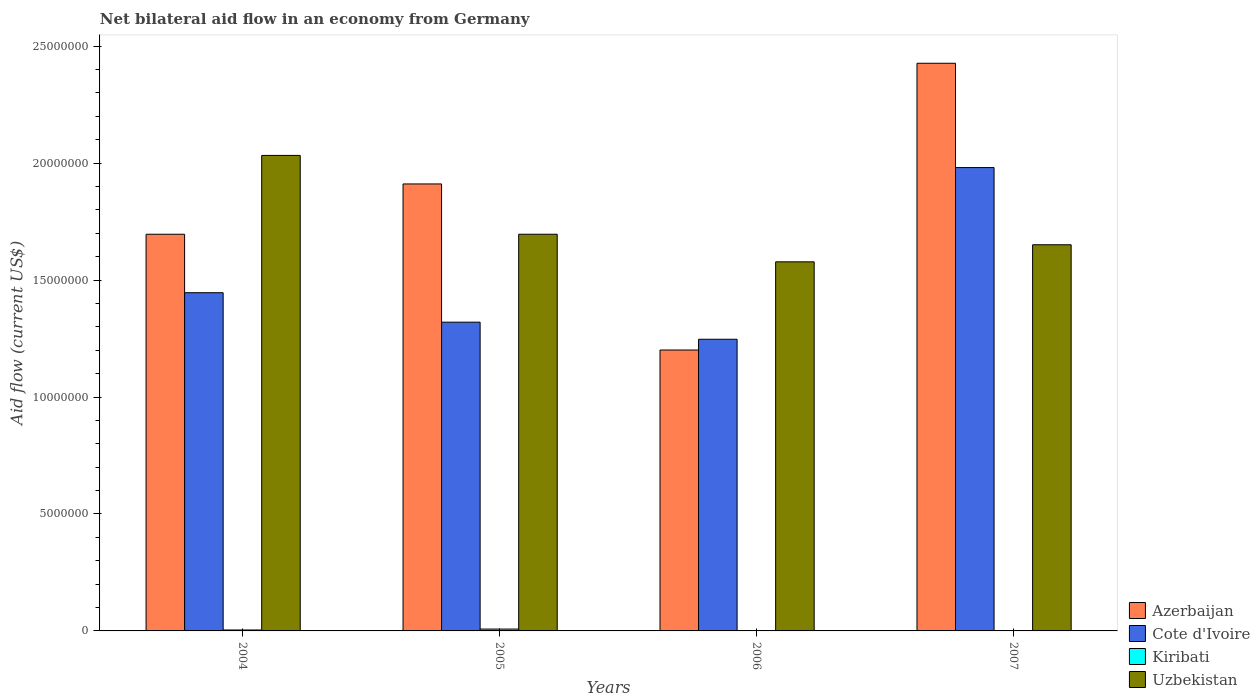How many groups of bars are there?
Make the answer very short. 4. Are the number of bars per tick equal to the number of legend labels?
Your response must be concise. Yes. How many bars are there on the 1st tick from the right?
Provide a short and direct response. 4. In how many cases, is the number of bars for a given year not equal to the number of legend labels?
Make the answer very short. 0. What is the net bilateral aid flow in Uzbekistan in 2005?
Offer a terse response. 1.70e+07. Across all years, what is the maximum net bilateral aid flow in Azerbaijan?
Offer a very short reply. 2.43e+07. Across all years, what is the minimum net bilateral aid flow in Uzbekistan?
Ensure brevity in your answer.  1.58e+07. What is the total net bilateral aid flow in Cote d'Ivoire in the graph?
Make the answer very short. 5.99e+07. What is the difference between the net bilateral aid flow in Uzbekistan in 2004 and that in 2007?
Your answer should be compact. 3.82e+06. What is the difference between the net bilateral aid flow in Cote d'Ivoire in 2007 and the net bilateral aid flow in Azerbaijan in 2005?
Your answer should be compact. 7.00e+05. What is the average net bilateral aid flow in Azerbaijan per year?
Keep it short and to the point. 1.81e+07. In the year 2005, what is the difference between the net bilateral aid flow in Cote d'Ivoire and net bilateral aid flow in Azerbaijan?
Keep it short and to the point. -5.91e+06. In how many years, is the net bilateral aid flow in Kiribati greater than 10000000 US$?
Make the answer very short. 0. What is the ratio of the net bilateral aid flow in Uzbekistan in 2004 to that in 2007?
Your answer should be compact. 1.23. Is the difference between the net bilateral aid flow in Cote d'Ivoire in 2004 and 2006 greater than the difference between the net bilateral aid flow in Azerbaijan in 2004 and 2006?
Provide a succinct answer. No. What is the difference between the highest and the second highest net bilateral aid flow in Azerbaijan?
Your answer should be very brief. 5.16e+06. What is the difference between the highest and the lowest net bilateral aid flow in Uzbekistan?
Your response must be concise. 4.55e+06. In how many years, is the net bilateral aid flow in Kiribati greater than the average net bilateral aid flow in Kiribati taken over all years?
Provide a short and direct response. 2. What does the 4th bar from the left in 2007 represents?
Your answer should be very brief. Uzbekistan. What does the 3rd bar from the right in 2006 represents?
Your response must be concise. Cote d'Ivoire. How many bars are there?
Ensure brevity in your answer.  16. What is the difference between two consecutive major ticks on the Y-axis?
Make the answer very short. 5.00e+06. Are the values on the major ticks of Y-axis written in scientific E-notation?
Make the answer very short. No. Where does the legend appear in the graph?
Your answer should be very brief. Bottom right. How are the legend labels stacked?
Offer a very short reply. Vertical. What is the title of the graph?
Offer a very short reply. Net bilateral aid flow in an economy from Germany. What is the label or title of the Y-axis?
Provide a succinct answer. Aid flow (current US$). What is the Aid flow (current US$) of Azerbaijan in 2004?
Ensure brevity in your answer.  1.70e+07. What is the Aid flow (current US$) of Cote d'Ivoire in 2004?
Your answer should be compact. 1.45e+07. What is the Aid flow (current US$) of Uzbekistan in 2004?
Your response must be concise. 2.03e+07. What is the Aid flow (current US$) of Azerbaijan in 2005?
Your answer should be compact. 1.91e+07. What is the Aid flow (current US$) of Cote d'Ivoire in 2005?
Offer a very short reply. 1.32e+07. What is the Aid flow (current US$) of Uzbekistan in 2005?
Give a very brief answer. 1.70e+07. What is the Aid flow (current US$) in Azerbaijan in 2006?
Your answer should be compact. 1.20e+07. What is the Aid flow (current US$) of Cote d'Ivoire in 2006?
Your answer should be very brief. 1.25e+07. What is the Aid flow (current US$) of Kiribati in 2006?
Your answer should be compact. 10000. What is the Aid flow (current US$) in Uzbekistan in 2006?
Ensure brevity in your answer.  1.58e+07. What is the Aid flow (current US$) in Azerbaijan in 2007?
Provide a short and direct response. 2.43e+07. What is the Aid flow (current US$) in Cote d'Ivoire in 2007?
Keep it short and to the point. 1.98e+07. What is the Aid flow (current US$) of Uzbekistan in 2007?
Offer a terse response. 1.65e+07. Across all years, what is the maximum Aid flow (current US$) in Azerbaijan?
Make the answer very short. 2.43e+07. Across all years, what is the maximum Aid flow (current US$) of Cote d'Ivoire?
Your answer should be very brief. 1.98e+07. Across all years, what is the maximum Aid flow (current US$) of Kiribati?
Offer a very short reply. 8.00e+04. Across all years, what is the maximum Aid flow (current US$) in Uzbekistan?
Ensure brevity in your answer.  2.03e+07. Across all years, what is the minimum Aid flow (current US$) in Azerbaijan?
Your answer should be compact. 1.20e+07. Across all years, what is the minimum Aid flow (current US$) of Cote d'Ivoire?
Ensure brevity in your answer.  1.25e+07. Across all years, what is the minimum Aid flow (current US$) of Uzbekistan?
Provide a short and direct response. 1.58e+07. What is the total Aid flow (current US$) in Azerbaijan in the graph?
Provide a succinct answer. 7.24e+07. What is the total Aid flow (current US$) in Cote d'Ivoire in the graph?
Provide a succinct answer. 5.99e+07. What is the total Aid flow (current US$) of Uzbekistan in the graph?
Provide a short and direct response. 6.96e+07. What is the difference between the Aid flow (current US$) in Azerbaijan in 2004 and that in 2005?
Keep it short and to the point. -2.15e+06. What is the difference between the Aid flow (current US$) of Cote d'Ivoire in 2004 and that in 2005?
Keep it short and to the point. 1.26e+06. What is the difference between the Aid flow (current US$) in Uzbekistan in 2004 and that in 2005?
Make the answer very short. 3.37e+06. What is the difference between the Aid flow (current US$) in Azerbaijan in 2004 and that in 2006?
Make the answer very short. 4.95e+06. What is the difference between the Aid flow (current US$) in Cote d'Ivoire in 2004 and that in 2006?
Your answer should be compact. 1.99e+06. What is the difference between the Aid flow (current US$) of Uzbekistan in 2004 and that in 2006?
Offer a very short reply. 4.55e+06. What is the difference between the Aid flow (current US$) of Azerbaijan in 2004 and that in 2007?
Keep it short and to the point. -7.31e+06. What is the difference between the Aid flow (current US$) of Cote d'Ivoire in 2004 and that in 2007?
Your answer should be very brief. -5.35e+06. What is the difference between the Aid flow (current US$) of Kiribati in 2004 and that in 2007?
Make the answer very short. 3.00e+04. What is the difference between the Aid flow (current US$) in Uzbekistan in 2004 and that in 2007?
Offer a terse response. 3.82e+06. What is the difference between the Aid flow (current US$) of Azerbaijan in 2005 and that in 2006?
Your answer should be very brief. 7.10e+06. What is the difference between the Aid flow (current US$) of Cote d'Ivoire in 2005 and that in 2006?
Your answer should be very brief. 7.30e+05. What is the difference between the Aid flow (current US$) of Kiribati in 2005 and that in 2006?
Provide a short and direct response. 7.00e+04. What is the difference between the Aid flow (current US$) in Uzbekistan in 2005 and that in 2006?
Keep it short and to the point. 1.18e+06. What is the difference between the Aid flow (current US$) of Azerbaijan in 2005 and that in 2007?
Your response must be concise. -5.16e+06. What is the difference between the Aid flow (current US$) of Cote d'Ivoire in 2005 and that in 2007?
Make the answer very short. -6.61e+06. What is the difference between the Aid flow (current US$) in Kiribati in 2005 and that in 2007?
Ensure brevity in your answer.  7.00e+04. What is the difference between the Aid flow (current US$) of Azerbaijan in 2006 and that in 2007?
Offer a terse response. -1.23e+07. What is the difference between the Aid flow (current US$) in Cote d'Ivoire in 2006 and that in 2007?
Offer a very short reply. -7.34e+06. What is the difference between the Aid flow (current US$) in Uzbekistan in 2006 and that in 2007?
Give a very brief answer. -7.30e+05. What is the difference between the Aid flow (current US$) in Azerbaijan in 2004 and the Aid flow (current US$) in Cote d'Ivoire in 2005?
Provide a short and direct response. 3.76e+06. What is the difference between the Aid flow (current US$) of Azerbaijan in 2004 and the Aid flow (current US$) of Kiribati in 2005?
Provide a short and direct response. 1.69e+07. What is the difference between the Aid flow (current US$) of Cote d'Ivoire in 2004 and the Aid flow (current US$) of Kiribati in 2005?
Make the answer very short. 1.44e+07. What is the difference between the Aid flow (current US$) in Cote d'Ivoire in 2004 and the Aid flow (current US$) in Uzbekistan in 2005?
Keep it short and to the point. -2.50e+06. What is the difference between the Aid flow (current US$) of Kiribati in 2004 and the Aid flow (current US$) of Uzbekistan in 2005?
Your response must be concise. -1.69e+07. What is the difference between the Aid flow (current US$) in Azerbaijan in 2004 and the Aid flow (current US$) in Cote d'Ivoire in 2006?
Ensure brevity in your answer.  4.49e+06. What is the difference between the Aid flow (current US$) of Azerbaijan in 2004 and the Aid flow (current US$) of Kiribati in 2006?
Your answer should be compact. 1.70e+07. What is the difference between the Aid flow (current US$) of Azerbaijan in 2004 and the Aid flow (current US$) of Uzbekistan in 2006?
Your response must be concise. 1.18e+06. What is the difference between the Aid flow (current US$) in Cote d'Ivoire in 2004 and the Aid flow (current US$) in Kiribati in 2006?
Your answer should be very brief. 1.44e+07. What is the difference between the Aid flow (current US$) in Cote d'Ivoire in 2004 and the Aid flow (current US$) in Uzbekistan in 2006?
Your answer should be compact. -1.32e+06. What is the difference between the Aid flow (current US$) of Kiribati in 2004 and the Aid flow (current US$) of Uzbekistan in 2006?
Keep it short and to the point. -1.57e+07. What is the difference between the Aid flow (current US$) of Azerbaijan in 2004 and the Aid flow (current US$) of Cote d'Ivoire in 2007?
Your response must be concise. -2.85e+06. What is the difference between the Aid flow (current US$) in Azerbaijan in 2004 and the Aid flow (current US$) in Kiribati in 2007?
Provide a succinct answer. 1.70e+07. What is the difference between the Aid flow (current US$) in Azerbaijan in 2004 and the Aid flow (current US$) in Uzbekistan in 2007?
Your answer should be very brief. 4.50e+05. What is the difference between the Aid flow (current US$) in Cote d'Ivoire in 2004 and the Aid flow (current US$) in Kiribati in 2007?
Make the answer very short. 1.44e+07. What is the difference between the Aid flow (current US$) in Cote d'Ivoire in 2004 and the Aid flow (current US$) in Uzbekistan in 2007?
Keep it short and to the point. -2.05e+06. What is the difference between the Aid flow (current US$) of Kiribati in 2004 and the Aid flow (current US$) of Uzbekistan in 2007?
Offer a very short reply. -1.65e+07. What is the difference between the Aid flow (current US$) of Azerbaijan in 2005 and the Aid flow (current US$) of Cote d'Ivoire in 2006?
Make the answer very short. 6.64e+06. What is the difference between the Aid flow (current US$) of Azerbaijan in 2005 and the Aid flow (current US$) of Kiribati in 2006?
Your response must be concise. 1.91e+07. What is the difference between the Aid flow (current US$) in Azerbaijan in 2005 and the Aid flow (current US$) in Uzbekistan in 2006?
Offer a very short reply. 3.33e+06. What is the difference between the Aid flow (current US$) of Cote d'Ivoire in 2005 and the Aid flow (current US$) of Kiribati in 2006?
Your answer should be very brief. 1.32e+07. What is the difference between the Aid flow (current US$) of Cote d'Ivoire in 2005 and the Aid flow (current US$) of Uzbekistan in 2006?
Ensure brevity in your answer.  -2.58e+06. What is the difference between the Aid flow (current US$) in Kiribati in 2005 and the Aid flow (current US$) in Uzbekistan in 2006?
Offer a terse response. -1.57e+07. What is the difference between the Aid flow (current US$) in Azerbaijan in 2005 and the Aid flow (current US$) in Cote d'Ivoire in 2007?
Provide a short and direct response. -7.00e+05. What is the difference between the Aid flow (current US$) of Azerbaijan in 2005 and the Aid flow (current US$) of Kiribati in 2007?
Make the answer very short. 1.91e+07. What is the difference between the Aid flow (current US$) of Azerbaijan in 2005 and the Aid flow (current US$) of Uzbekistan in 2007?
Provide a succinct answer. 2.60e+06. What is the difference between the Aid flow (current US$) in Cote d'Ivoire in 2005 and the Aid flow (current US$) in Kiribati in 2007?
Give a very brief answer. 1.32e+07. What is the difference between the Aid flow (current US$) in Cote d'Ivoire in 2005 and the Aid flow (current US$) in Uzbekistan in 2007?
Provide a succinct answer. -3.31e+06. What is the difference between the Aid flow (current US$) of Kiribati in 2005 and the Aid flow (current US$) of Uzbekistan in 2007?
Give a very brief answer. -1.64e+07. What is the difference between the Aid flow (current US$) of Azerbaijan in 2006 and the Aid flow (current US$) of Cote d'Ivoire in 2007?
Keep it short and to the point. -7.80e+06. What is the difference between the Aid flow (current US$) in Azerbaijan in 2006 and the Aid flow (current US$) in Kiribati in 2007?
Make the answer very short. 1.20e+07. What is the difference between the Aid flow (current US$) in Azerbaijan in 2006 and the Aid flow (current US$) in Uzbekistan in 2007?
Offer a very short reply. -4.50e+06. What is the difference between the Aid flow (current US$) of Cote d'Ivoire in 2006 and the Aid flow (current US$) of Kiribati in 2007?
Your answer should be compact. 1.25e+07. What is the difference between the Aid flow (current US$) in Cote d'Ivoire in 2006 and the Aid flow (current US$) in Uzbekistan in 2007?
Provide a succinct answer. -4.04e+06. What is the difference between the Aid flow (current US$) of Kiribati in 2006 and the Aid flow (current US$) of Uzbekistan in 2007?
Provide a short and direct response. -1.65e+07. What is the average Aid flow (current US$) of Azerbaijan per year?
Provide a succinct answer. 1.81e+07. What is the average Aid flow (current US$) in Cote d'Ivoire per year?
Your answer should be compact. 1.50e+07. What is the average Aid flow (current US$) in Kiribati per year?
Keep it short and to the point. 3.50e+04. What is the average Aid flow (current US$) in Uzbekistan per year?
Provide a short and direct response. 1.74e+07. In the year 2004, what is the difference between the Aid flow (current US$) in Azerbaijan and Aid flow (current US$) in Cote d'Ivoire?
Your response must be concise. 2.50e+06. In the year 2004, what is the difference between the Aid flow (current US$) in Azerbaijan and Aid flow (current US$) in Kiribati?
Make the answer very short. 1.69e+07. In the year 2004, what is the difference between the Aid flow (current US$) in Azerbaijan and Aid flow (current US$) in Uzbekistan?
Ensure brevity in your answer.  -3.37e+06. In the year 2004, what is the difference between the Aid flow (current US$) in Cote d'Ivoire and Aid flow (current US$) in Kiribati?
Keep it short and to the point. 1.44e+07. In the year 2004, what is the difference between the Aid flow (current US$) in Cote d'Ivoire and Aid flow (current US$) in Uzbekistan?
Your response must be concise. -5.87e+06. In the year 2004, what is the difference between the Aid flow (current US$) in Kiribati and Aid flow (current US$) in Uzbekistan?
Keep it short and to the point. -2.03e+07. In the year 2005, what is the difference between the Aid flow (current US$) of Azerbaijan and Aid flow (current US$) of Cote d'Ivoire?
Your response must be concise. 5.91e+06. In the year 2005, what is the difference between the Aid flow (current US$) of Azerbaijan and Aid flow (current US$) of Kiribati?
Ensure brevity in your answer.  1.90e+07. In the year 2005, what is the difference between the Aid flow (current US$) of Azerbaijan and Aid flow (current US$) of Uzbekistan?
Your response must be concise. 2.15e+06. In the year 2005, what is the difference between the Aid flow (current US$) in Cote d'Ivoire and Aid flow (current US$) in Kiribati?
Keep it short and to the point. 1.31e+07. In the year 2005, what is the difference between the Aid flow (current US$) of Cote d'Ivoire and Aid flow (current US$) of Uzbekistan?
Your answer should be very brief. -3.76e+06. In the year 2005, what is the difference between the Aid flow (current US$) of Kiribati and Aid flow (current US$) of Uzbekistan?
Offer a very short reply. -1.69e+07. In the year 2006, what is the difference between the Aid flow (current US$) of Azerbaijan and Aid flow (current US$) of Cote d'Ivoire?
Keep it short and to the point. -4.60e+05. In the year 2006, what is the difference between the Aid flow (current US$) in Azerbaijan and Aid flow (current US$) in Kiribati?
Keep it short and to the point. 1.20e+07. In the year 2006, what is the difference between the Aid flow (current US$) in Azerbaijan and Aid flow (current US$) in Uzbekistan?
Your response must be concise. -3.77e+06. In the year 2006, what is the difference between the Aid flow (current US$) of Cote d'Ivoire and Aid flow (current US$) of Kiribati?
Keep it short and to the point. 1.25e+07. In the year 2006, what is the difference between the Aid flow (current US$) in Cote d'Ivoire and Aid flow (current US$) in Uzbekistan?
Your answer should be compact. -3.31e+06. In the year 2006, what is the difference between the Aid flow (current US$) in Kiribati and Aid flow (current US$) in Uzbekistan?
Ensure brevity in your answer.  -1.58e+07. In the year 2007, what is the difference between the Aid flow (current US$) in Azerbaijan and Aid flow (current US$) in Cote d'Ivoire?
Your answer should be very brief. 4.46e+06. In the year 2007, what is the difference between the Aid flow (current US$) in Azerbaijan and Aid flow (current US$) in Kiribati?
Your answer should be very brief. 2.43e+07. In the year 2007, what is the difference between the Aid flow (current US$) in Azerbaijan and Aid flow (current US$) in Uzbekistan?
Your answer should be very brief. 7.76e+06. In the year 2007, what is the difference between the Aid flow (current US$) in Cote d'Ivoire and Aid flow (current US$) in Kiribati?
Keep it short and to the point. 1.98e+07. In the year 2007, what is the difference between the Aid flow (current US$) of Cote d'Ivoire and Aid flow (current US$) of Uzbekistan?
Your response must be concise. 3.30e+06. In the year 2007, what is the difference between the Aid flow (current US$) in Kiribati and Aid flow (current US$) in Uzbekistan?
Give a very brief answer. -1.65e+07. What is the ratio of the Aid flow (current US$) of Azerbaijan in 2004 to that in 2005?
Offer a terse response. 0.89. What is the ratio of the Aid flow (current US$) in Cote d'Ivoire in 2004 to that in 2005?
Offer a very short reply. 1.1. What is the ratio of the Aid flow (current US$) in Uzbekistan in 2004 to that in 2005?
Give a very brief answer. 1.2. What is the ratio of the Aid flow (current US$) of Azerbaijan in 2004 to that in 2006?
Provide a short and direct response. 1.41. What is the ratio of the Aid flow (current US$) of Cote d'Ivoire in 2004 to that in 2006?
Provide a short and direct response. 1.16. What is the ratio of the Aid flow (current US$) of Kiribati in 2004 to that in 2006?
Your answer should be very brief. 4. What is the ratio of the Aid flow (current US$) in Uzbekistan in 2004 to that in 2006?
Give a very brief answer. 1.29. What is the ratio of the Aid flow (current US$) in Azerbaijan in 2004 to that in 2007?
Your response must be concise. 0.7. What is the ratio of the Aid flow (current US$) of Cote d'Ivoire in 2004 to that in 2007?
Your response must be concise. 0.73. What is the ratio of the Aid flow (current US$) of Kiribati in 2004 to that in 2007?
Your answer should be very brief. 4. What is the ratio of the Aid flow (current US$) in Uzbekistan in 2004 to that in 2007?
Your answer should be compact. 1.23. What is the ratio of the Aid flow (current US$) of Azerbaijan in 2005 to that in 2006?
Your response must be concise. 1.59. What is the ratio of the Aid flow (current US$) of Cote d'Ivoire in 2005 to that in 2006?
Make the answer very short. 1.06. What is the ratio of the Aid flow (current US$) of Kiribati in 2005 to that in 2006?
Give a very brief answer. 8. What is the ratio of the Aid flow (current US$) of Uzbekistan in 2005 to that in 2006?
Provide a short and direct response. 1.07. What is the ratio of the Aid flow (current US$) in Azerbaijan in 2005 to that in 2007?
Offer a terse response. 0.79. What is the ratio of the Aid flow (current US$) of Cote d'Ivoire in 2005 to that in 2007?
Provide a succinct answer. 0.67. What is the ratio of the Aid flow (current US$) in Kiribati in 2005 to that in 2007?
Your answer should be compact. 8. What is the ratio of the Aid flow (current US$) in Uzbekistan in 2005 to that in 2007?
Give a very brief answer. 1.03. What is the ratio of the Aid flow (current US$) in Azerbaijan in 2006 to that in 2007?
Your answer should be very brief. 0.49. What is the ratio of the Aid flow (current US$) of Cote d'Ivoire in 2006 to that in 2007?
Provide a short and direct response. 0.63. What is the ratio of the Aid flow (current US$) of Uzbekistan in 2006 to that in 2007?
Your response must be concise. 0.96. What is the difference between the highest and the second highest Aid flow (current US$) in Azerbaijan?
Your response must be concise. 5.16e+06. What is the difference between the highest and the second highest Aid flow (current US$) of Cote d'Ivoire?
Your response must be concise. 5.35e+06. What is the difference between the highest and the second highest Aid flow (current US$) in Kiribati?
Make the answer very short. 4.00e+04. What is the difference between the highest and the second highest Aid flow (current US$) of Uzbekistan?
Provide a short and direct response. 3.37e+06. What is the difference between the highest and the lowest Aid flow (current US$) in Azerbaijan?
Your response must be concise. 1.23e+07. What is the difference between the highest and the lowest Aid flow (current US$) of Cote d'Ivoire?
Offer a terse response. 7.34e+06. What is the difference between the highest and the lowest Aid flow (current US$) of Kiribati?
Offer a very short reply. 7.00e+04. What is the difference between the highest and the lowest Aid flow (current US$) of Uzbekistan?
Your answer should be compact. 4.55e+06. 